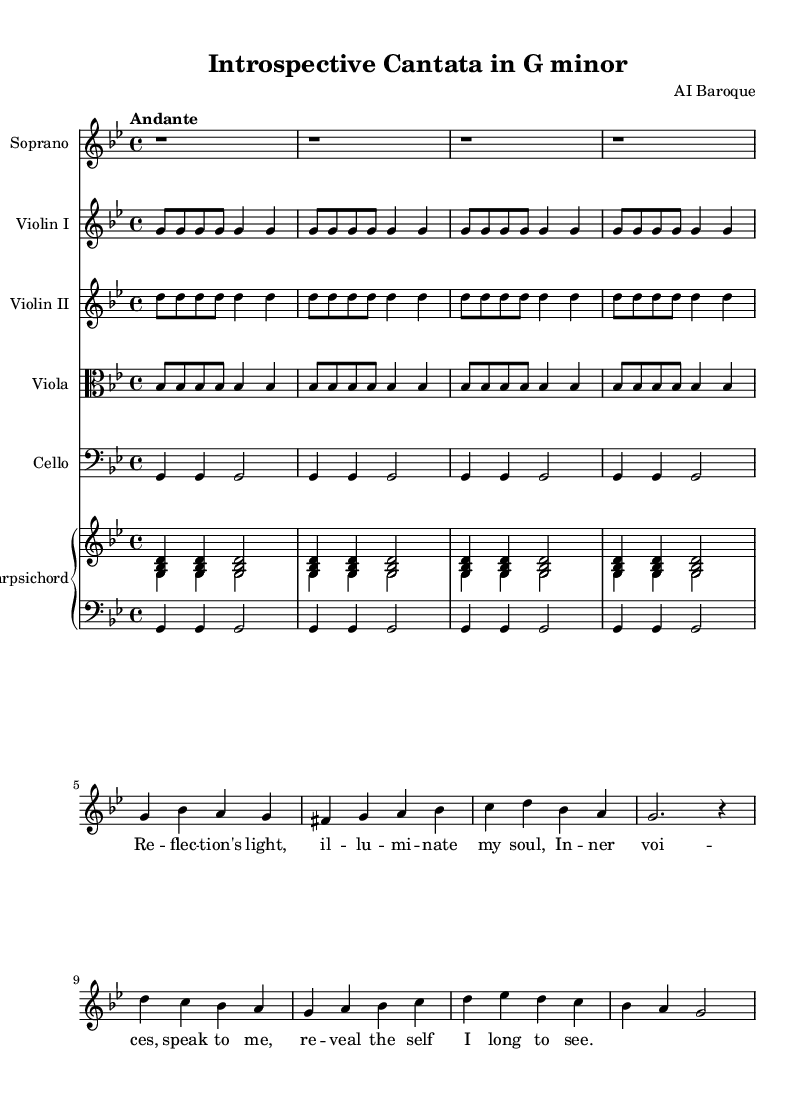What is the key signature of this music? The key signature has two flats, indicating that the piece is in G minor, which has B♭ and E♭.
Answer: G minor What is the time signature of this cantata? The time signature displayed is 4/4, which means there are four beats in each measure and the quarter note gets one beat.
Answer: 4/4 What is the tempo marking for this piece? The tempo marking "Andante" indicates a moderately slow pace, typically between 76 and 108 beats per minute.
Answer: Andante Which instrument plays the soprano voice? The soprano voice is notated in the treble clef, which is typical for high-pitched voices, and is indicated as the first staff.
Answer: Soprano Identify a recurring musical motif in the cantata. The motif played by both the violins consists of repeating quarter notes in a rhythmic pattern, establishing a pulse throughout the piece.
Answer: Repeating quarter notes What is the function of the harpsichord in this piece? The harpsichord provides both harmonic support and rhythmic emphasis, typically doubling the bass and filling the texture with chords during the piece.
Answer: Harmonic support 